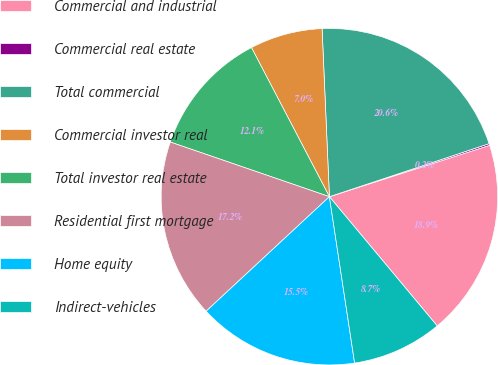Convert chart. <chart><loc_0><loc_0><loc_500><loc_500><pie_chart><fcel>Commercial and industrial<fcel>Commercial real estate<fcel>Total commercial<fcel>Commercial investor real<fcel>Total investor real estate<fcel>Residential first mortgage<fcel>Home equity<fcel>Indirect-vehicles<nl><fcel>18.88%<fcel>0.16%<fcel>20.59%<fcel>6.97%<fcel>12.07%<fcel>17.18%<fcel>15.48%<fcel>8.67%<nl></chart> 